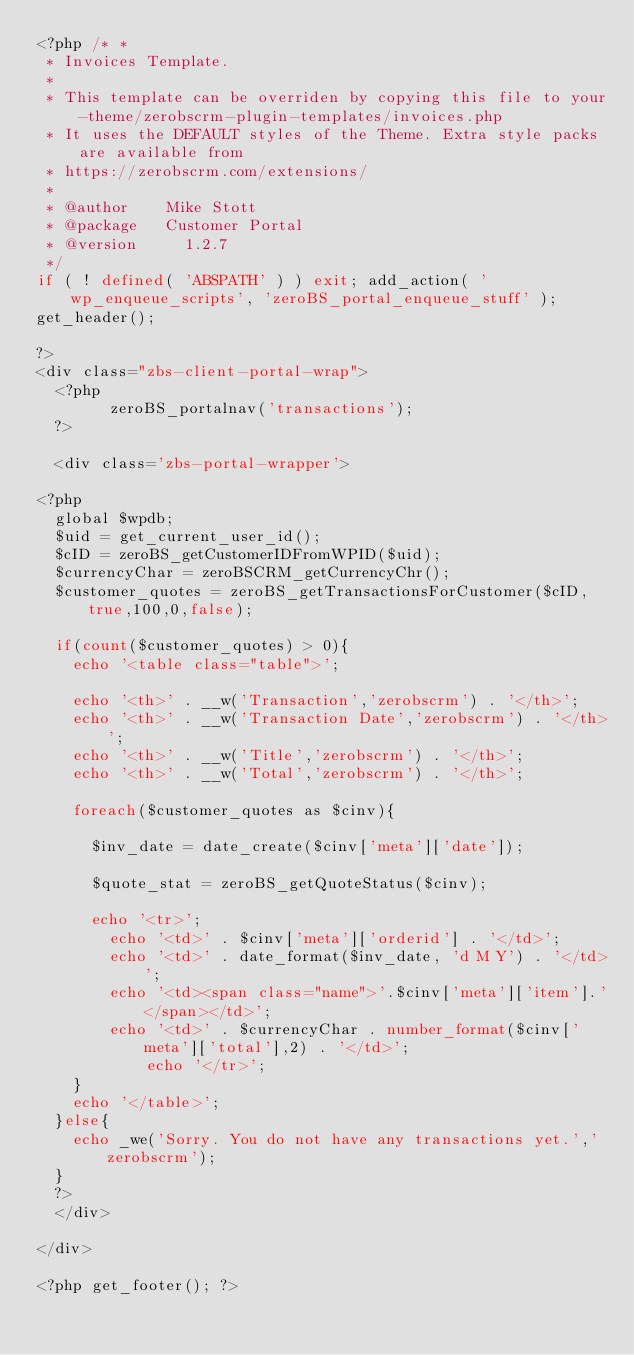<code> <loc_0><loc_0><loc_500><loc_500><_PHP_><?php /* *
 * Invoices Template.
 *
 * This template can be overriden by copying this file to your-theme/zerobscrm-plugin-templates/invoices.php
 * It uses the DEFAULT styles of the Theme. Extra style packs are available from 
 * https://zerobscrm.com/extensions/
 *
 * @author 		Mike Stott
 * @package 	Customer Portal
 * @version     1.2.7
 */
if ( ! defined( 'ABSPATH' ) ) exit; add_action( 'wp_enqueue_scripts', 'zeroBS_portal_enqueue_stuff' );
get_header();

?>
<div class="zbs-client-portal-wrap">
	<?php
				zeroBS_portalnav('transactions');
	?>

	<div class='zbs-portal-wrapper'>

<?php
	global $wpdb;
	$uid = get_current_user_id();
	$cID = zeroBS_getCustomerIDFromWPID($uid);
	$currencyChar = zeroBSCRM_getCurrencyChr();
	$customer_quotes = zeroBS_getTransactionsForCustomer($cID,true,100,0,false);

	if(count($customer_quotes) > 0){
		echo '<table class="table">';

		echo '<th>' . __w('Transaction','zerobscrm') . '</th>';
		echo '<th>' . __w('Transaction Date','zerobscrm') . '</th>';
		echo '<th>' . __w('Title','zerobscrm') . '</th>';
		echo '<th>' . __w('Total','zerobscrm') . '</th>';
		
		foreach($customer_quotes as $cinv){

			$inv_date = date_create($cinv['meta']['date']);

			$quote_stat = zeroBS_getQuoteStatus($cinv);

			echo '<tr>';
				echo '<td>' . $cinv['meta']['orderid'] . '</td>';
				echo '<td>' . date_format($inv_date, 'd M Y') . '</td>';
				echo '<td><span class="name">'.$cinv['meta']['item'].'</span></td>';
				echo '<td>' . $currencyChar . number_format($cinv['meta']['total'],2) . '</td>';
						echo '</tr>';
		}
		echo '</table>';
	}else{
		echo _we('Sorry. You do not have any transactions yet.','zerobscrm'); 
	}
	?>
	</div>

</div>

<?php get_footer(); ?></code> 